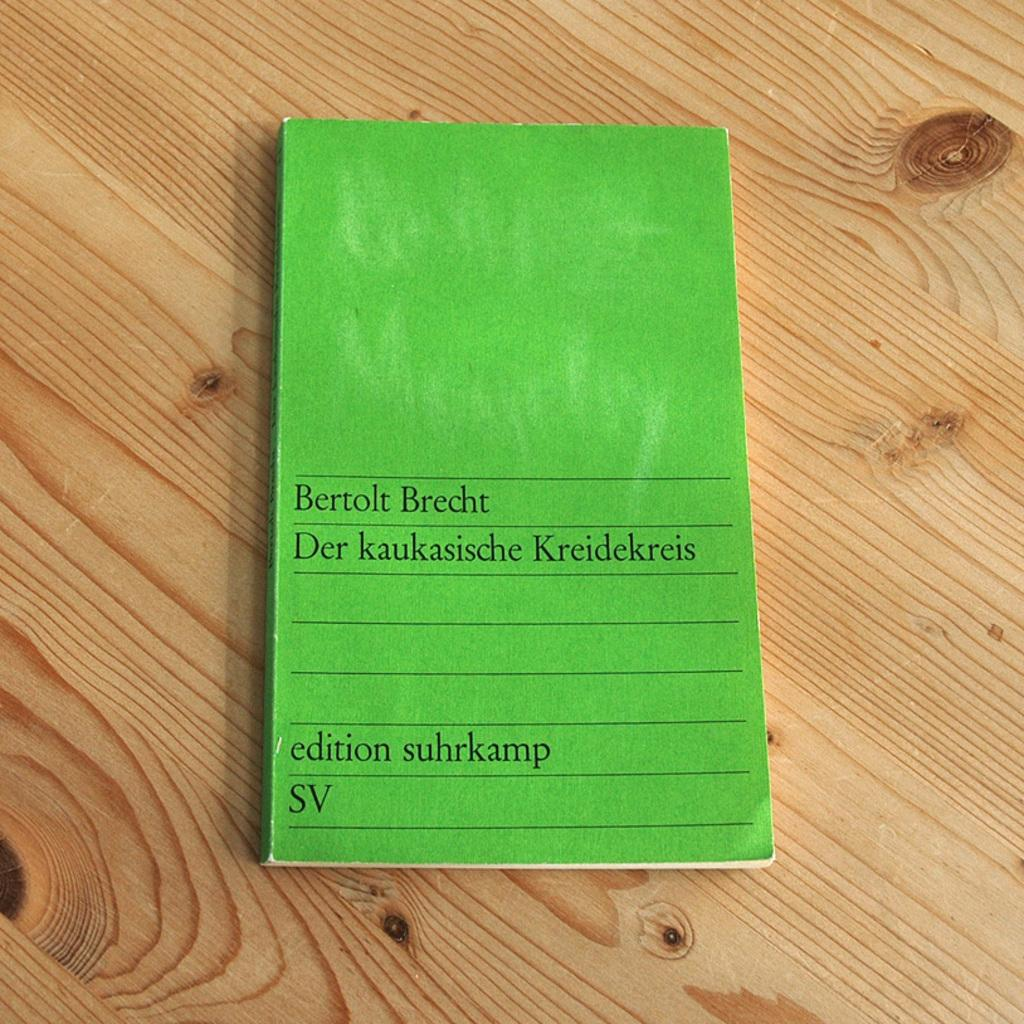What object is present on the table in the image? There is a book on the table in the image. What is the book resting on? The book is on a table. What can be seen on the cover page of the book? There is text on the cover page of the book. What type of beef is being discussed in the book? There is no mention of beef in the image or the book, as the facts provided only mention the presence of a book with text on the cover page. 